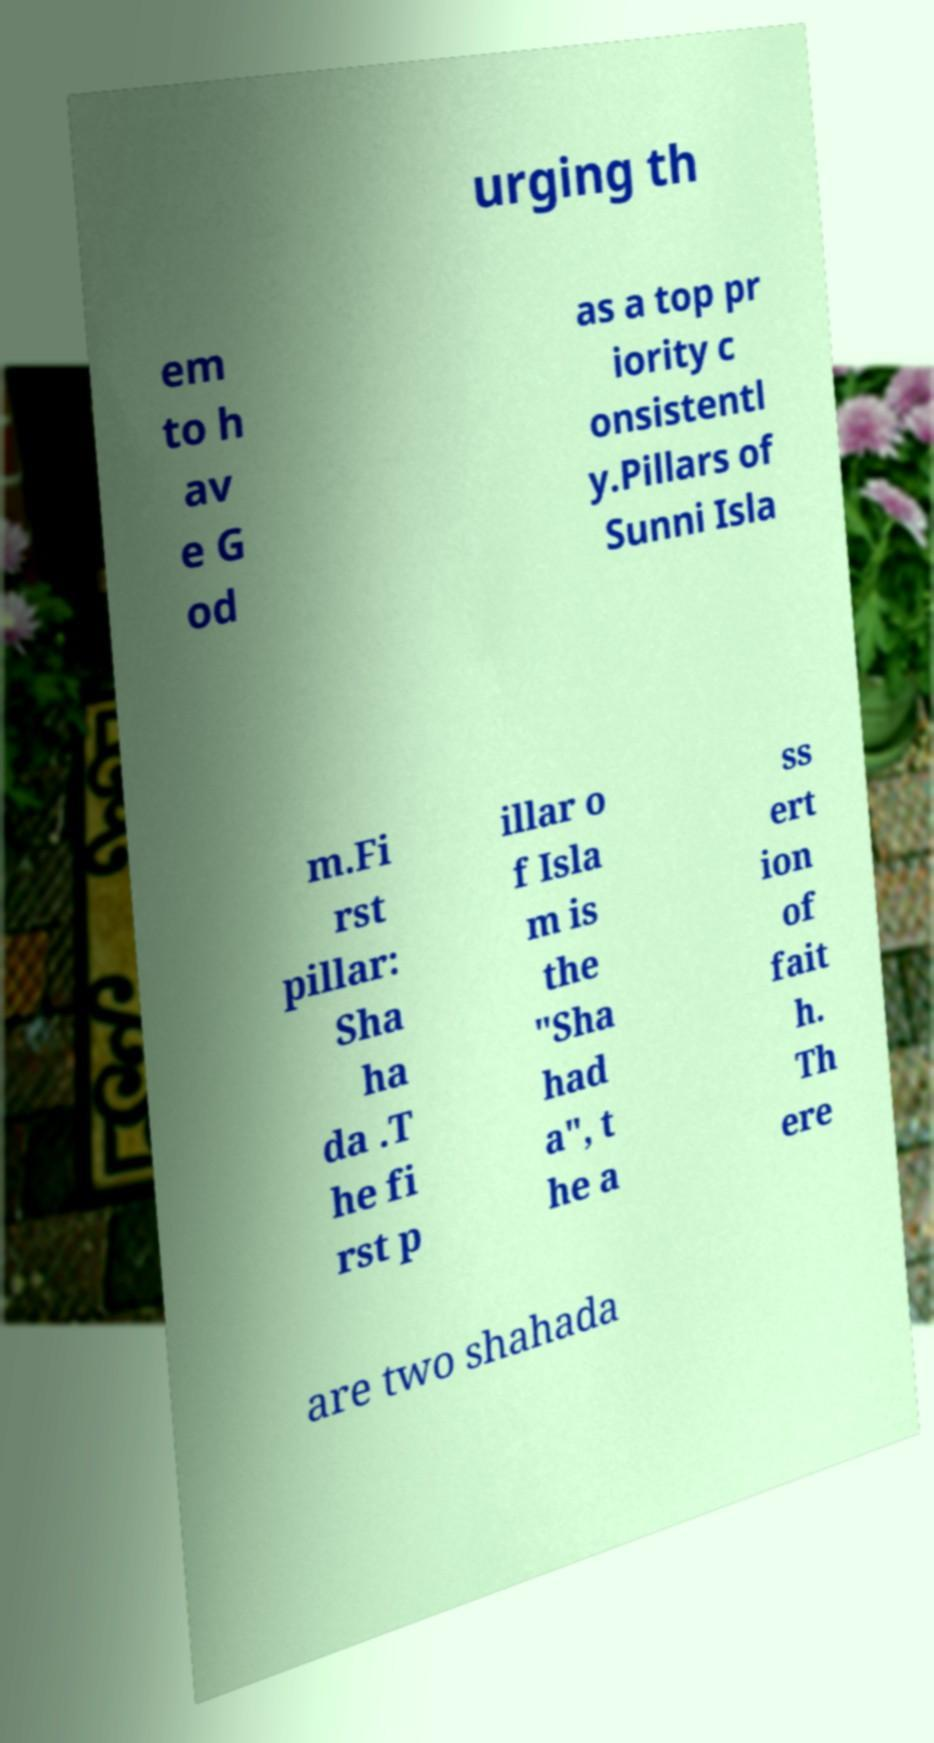Can you read and provide the text displayed in the image?This photo seems to have some interesting text. Can you extract and type it out for me? urging th em to h av e G od as a top pr iority c onsistentl y.Pillars of Sunni Isla m.Fi rst pillar: Sha ha da .T he fi rst p illar o f Isla m is the "Sha had a", t he a ss ert ion of fait h. Th ere are two shahada 